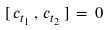Convert formula to latex. <formula><loc_0><loc_0><loc_500><loc_500>[ \, c _ { t _ { 1 } } \, , \, c _ { t _ { 2 } } \, ] \, = \, 0</formula> 